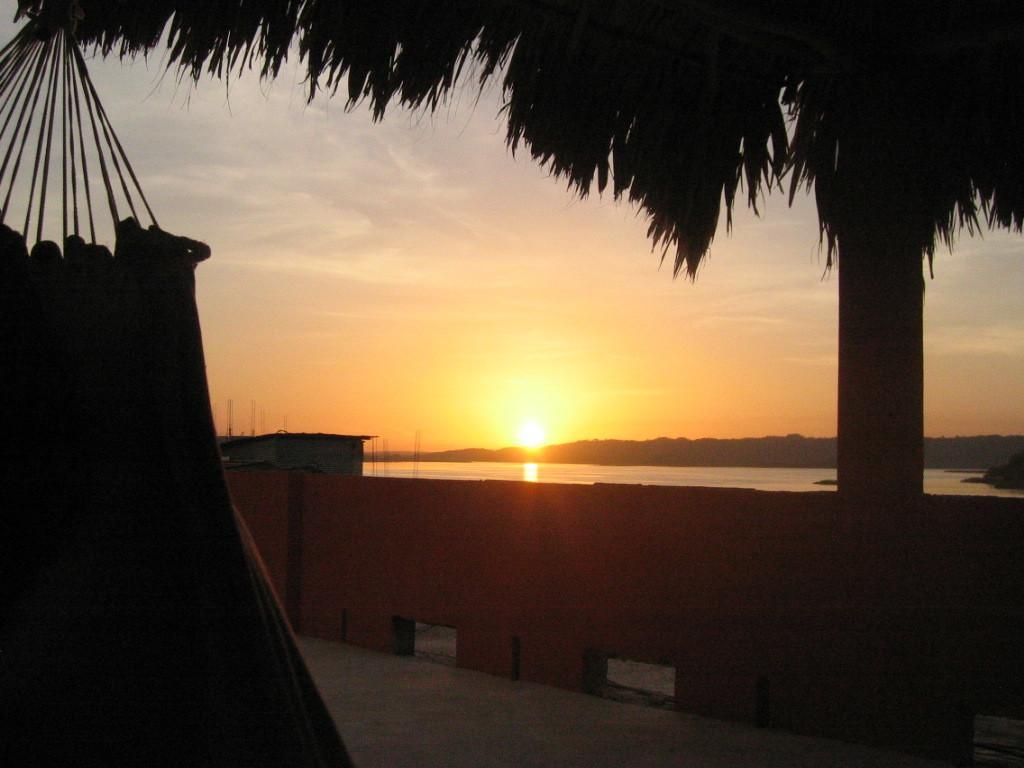How would you summarize this image in a sentence or two? In this image we can see a tree, an object looks like a cloth hanged to the tree, there is a wall, a shed, water, mountains and sun in the sky. 